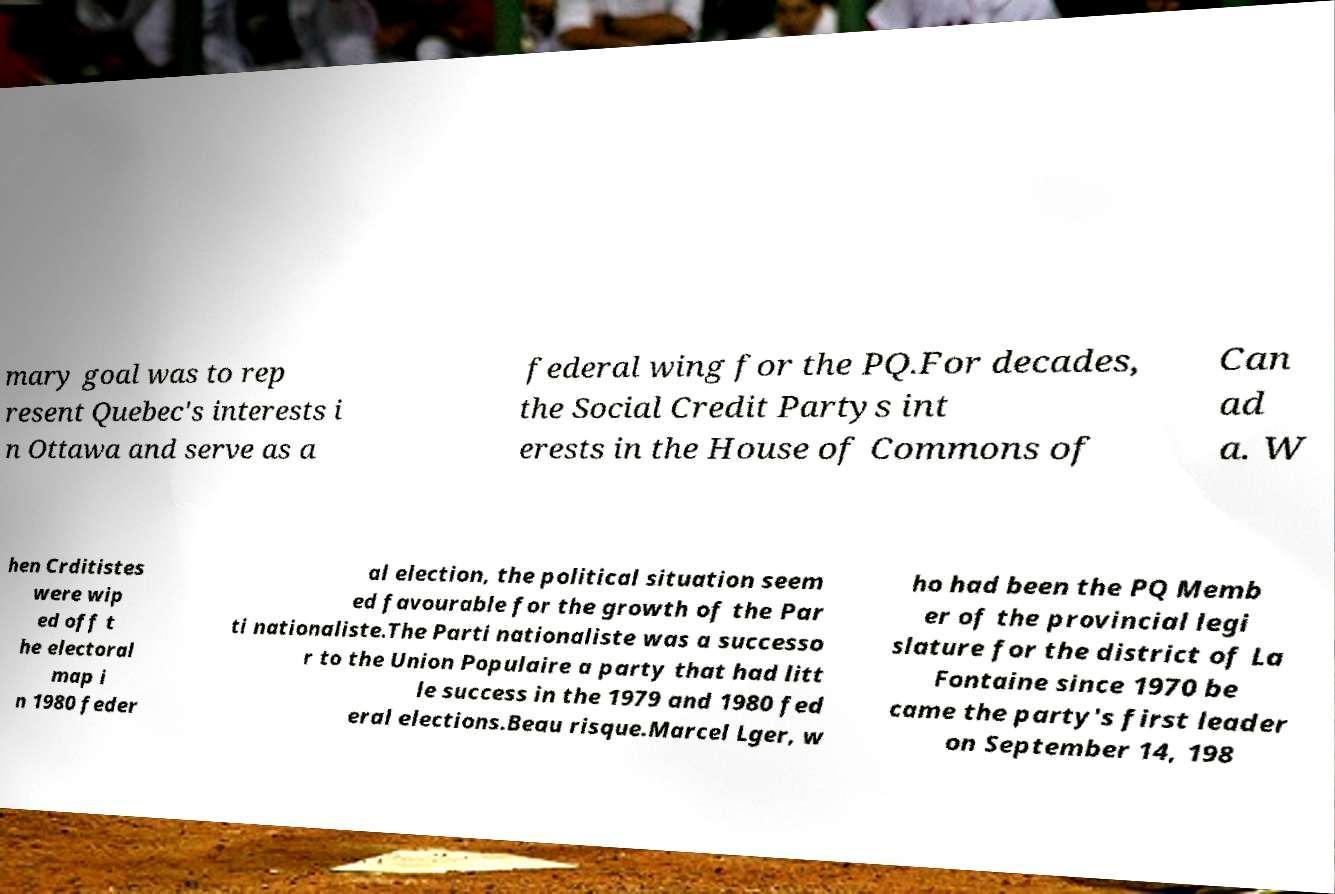For documentation purposes, I need the text within this image transcribed. Could you provide that? mary goal was to rep resent Quebec's interests i n Ottawa and serve as a federal wing for the PQ.For decades, the Social Credit Partys int erests in the House of Commons of Can ad a. W hen Crditistes were wip ed off t he electoral map i n 1980 feder al election, the political situation seem ed favourable for the growth of the Par ti nationaliste.The Parti nationaliste was a successo r to the Union Populaire a party that had litt le success in the 1979 and 1980 fed eral elections.Beau risque.Marcel Lger, w ho had been the PQ Memb er of the provincial legi slature for the district of La Fontaine since 1970 be came the party's first leader on September 14, 198 